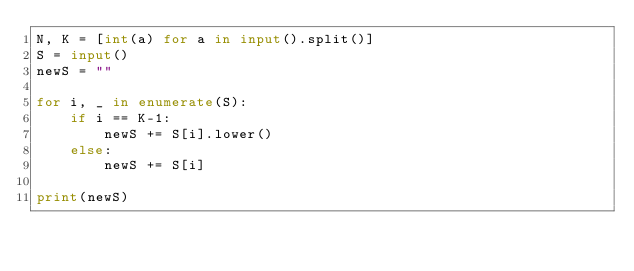Convert code to text. <code><loc_0><loc_0><loc_500><loc_500><_Python_>N, K = [int(a) for a in input().split()]
S = input()
newS = ""

for i, _ in enumerate(S):
    if i == K-1:
        newS += S[i].lower()
    else:
        newS += S[i]

print(newS)
</code> 